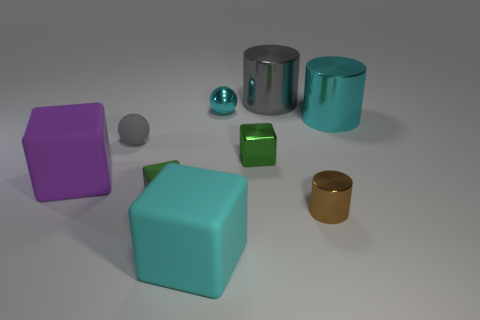Subtract all gray cylinders. How many cylinders are left? 2 Subtract 1 balls. How many balls are left? 1 Subtract all cylinders. How many objects are left? 6 Subtract all red cylinders. Subtract all purple spheres. How many cylinders are left? 3 Subtract all purple balls. How many red blocks are left? 0 Subtract all small green cubes. Subtract all small brown shiny balls. How many objects are left? 7 Add 5 large blocks. How many large blocks are left? 7 Add 3 big purple objects. How many big purple objects exist? 4 Subtract all cyan spheres. How many spheres are left? 1 Subtract 1 green cubes. How many objects are left? 8 